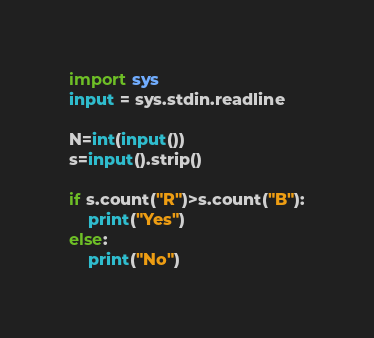Convert code to text. <code><loc_0><loc_0><loc_500><loc_500><_Python_>import sys
input = sys.stdin.readline

N=int(input())
s=input().strip()

if s.count("R")>s.count("B"):
    print("Yes")
else:
    print("No")
</code> 